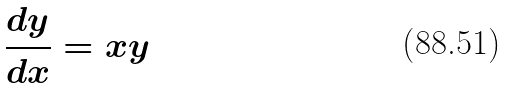Convert formula to latex. <formula><loc_0><loc_0><loc_500><loc_500>\frac { d y } { d x } = x y</formula> 